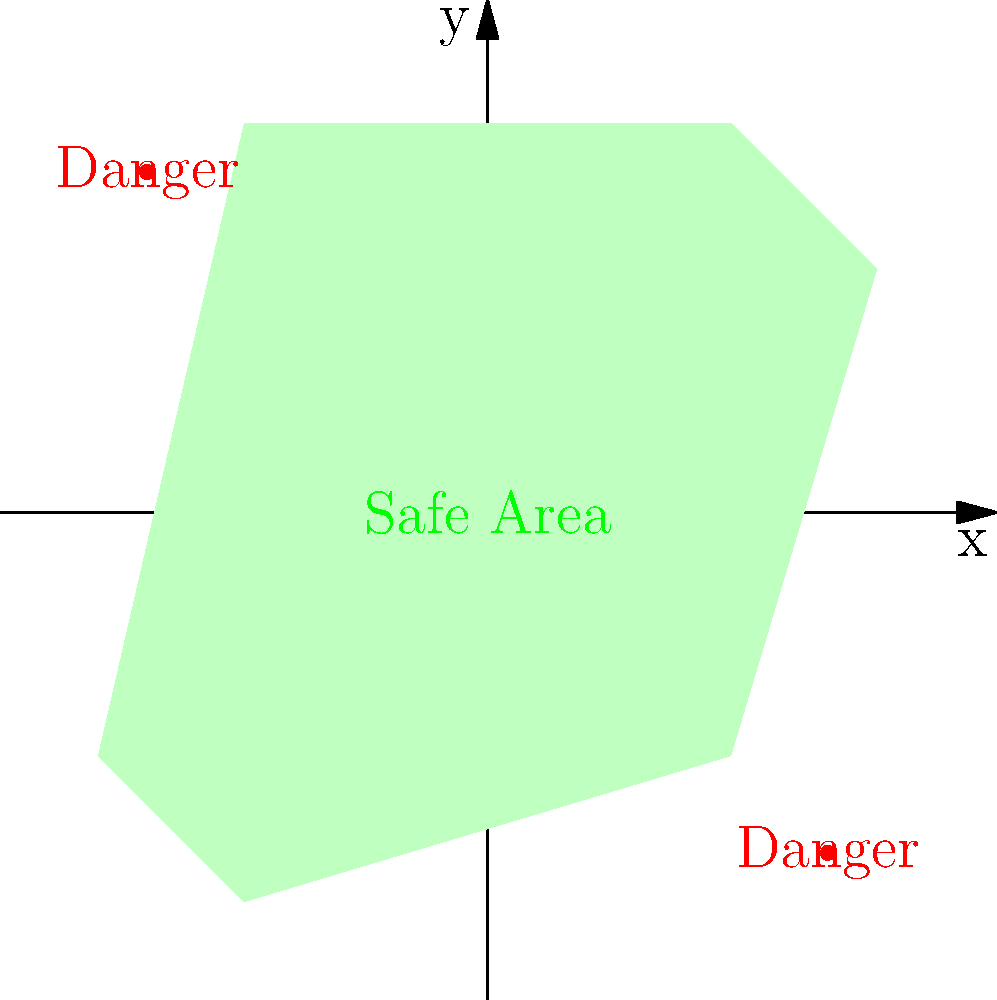Given the coordinate system shown in the diagram, determine the coordinates of the point that lies within the safe navigation area and is closest to the origin (0,0). Round your answer to the nearest whole number for each coordinate. To solve this problem, let's follow these steps:

1. Analyze the safe navigation area:
   The safe area is represented by the green polygon in the coordinate system.

2. Identify the vertices of the safe area:
   The vertices are approximately at (5,8), (8,5), (5,-5), (-5,-8), (-8,-5), and (-5,8).

3. Determine the point closest to the origin:
   The origin (0,0) is inside the safe area. The point within the safe area that's closest to the origin would be the origin itself.

4. Round the coordinates:
   Since the question asks for the nearest whole number, we round (0,0) to the nearest integers.

5. Verify the answer:
   (0,0) is indeed within the green safe navigation area and is the closest point to itself.

Therefore, the coordinates of the point within the safe navigation area closest to the origin, rounded to the nearest whole numbers, are (0,0).
Answer: (0,0) 